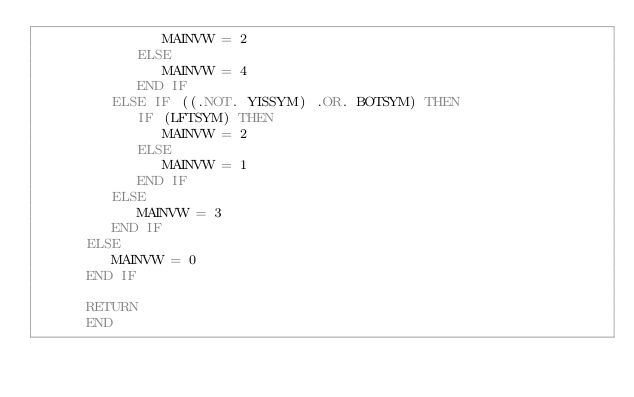<code> <loc_0><loc_0><loc_500><loc_500><_FORTRAN_>               MAINVW = 2
            ELSE
               MAINVW = 4
            END IF
         ELSE IF ((.NOT. YISSYM) .OR. BOTSYM) THEN
            IF (LFTSYM) THEN
               MAINVW = 2
            ELSE
               MAINVW = 1
            END IF
         ELSE
            MAINVW = 3
         END IF
      ELSE
         MAINVW = 0
      END IF

      RETURN
      END
</code> 